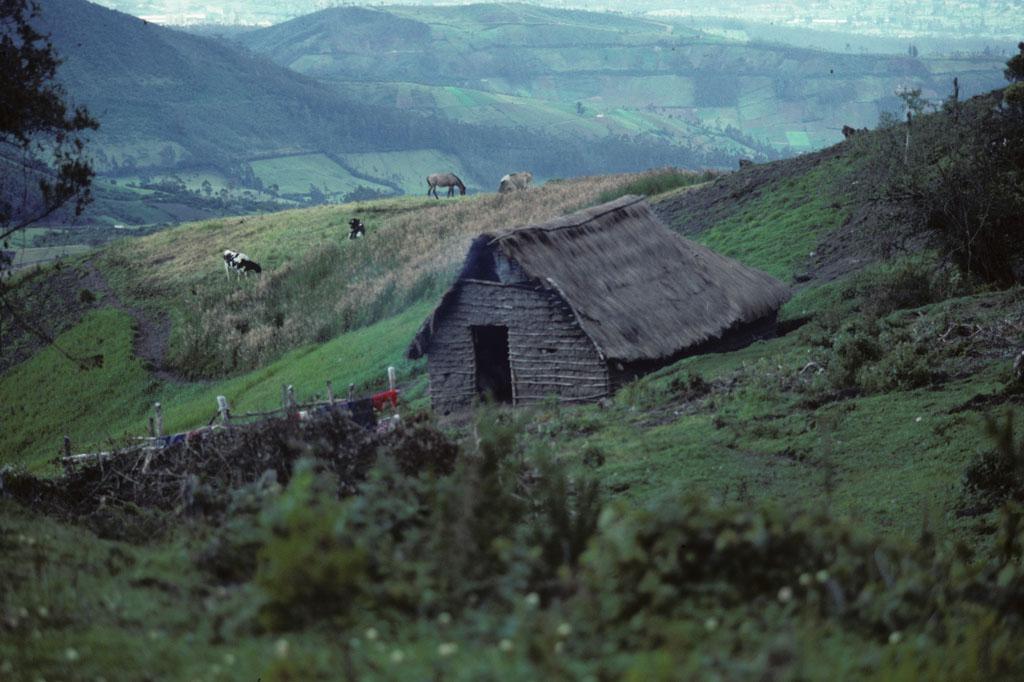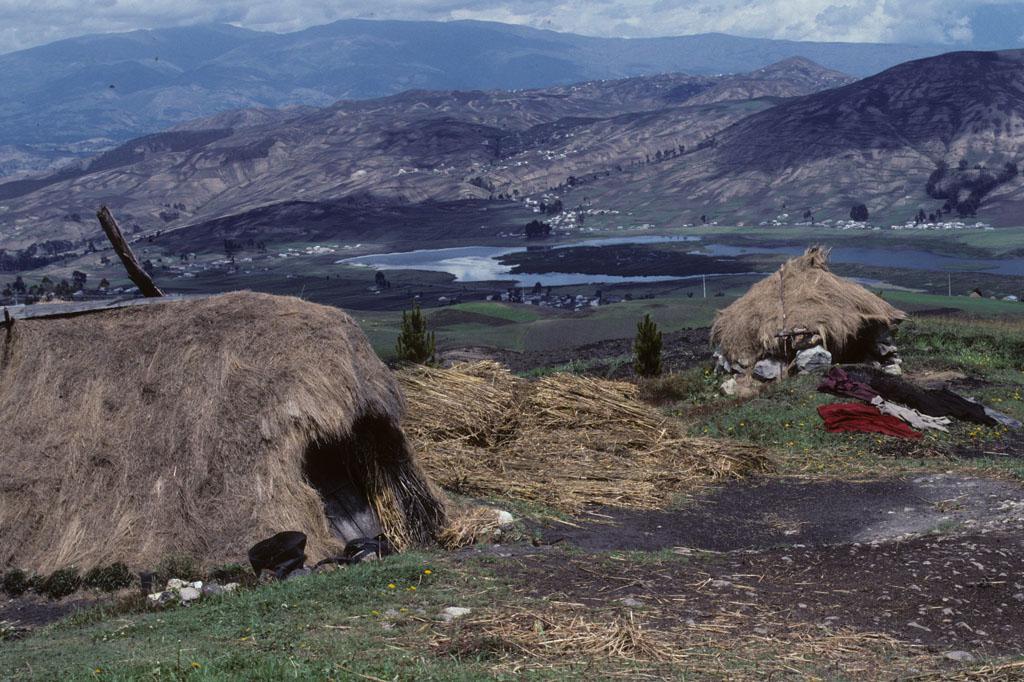The first image is the image on the left, the second image is the image on the right. Examine the images to the left and right. Is the description "In one image, a dwelling has a thatched roof over walls made of rows of stacked rocks." accurate? Answer yes or no. No. The first image is the image on the left, the second image is the image on the right. Examine the images to the left and right. Is the description "At least one person is standing on the ground outside of a building in one of the images." accurate? Answer yes or no. No. 